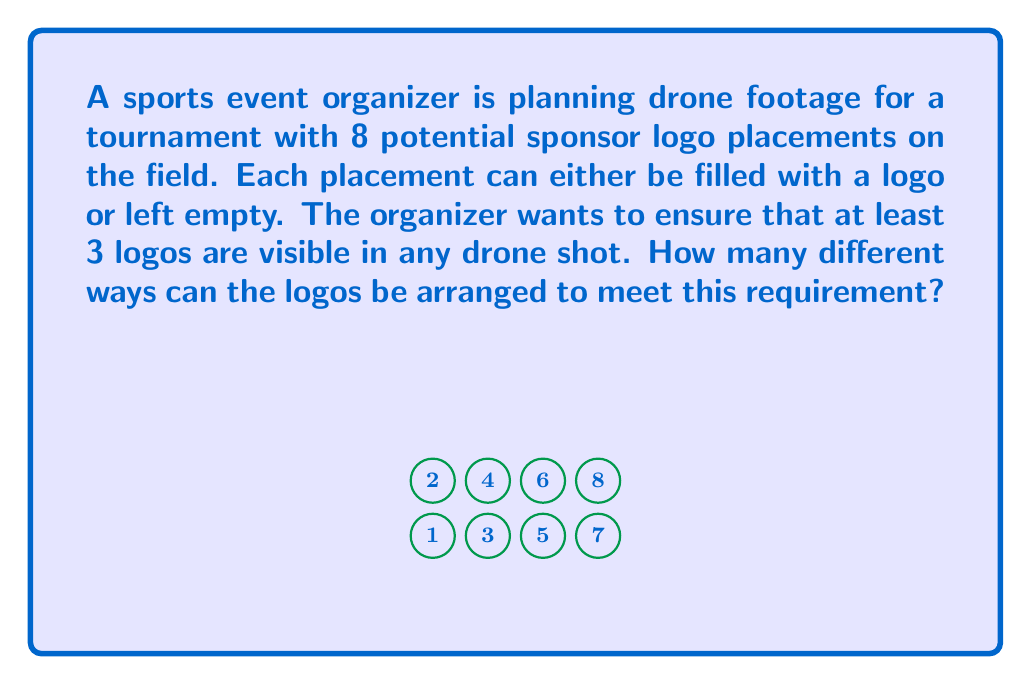Teach me how to tackle this problem. Let's approach this step-by-step:

1) First, we need to calculate the total number of ways to arrange logos in 8 spots. Each spot can be either filled or empty, so we have 2 choices for each spot. This gives us $2^8 = 256$ total arrangements.

2) However, we need to subtract the arrangements where fewer than 3 logos are used. Let's count these:
   - 0 logos: $\binom{8}{0} = 1$ way
   - 1 logo: $\binom{8}{1} = 8$ ways
   - 2 logos: $\binom{8}{2} = 28$ ways

3) The total number of arrangements with fewer than 3 logos is:
   $1 + 8 + 28 = 37$

4) Therefore, the number of valid arrangements is:
   $256 - 37 = 219$

This can also be expressed using the sum of combinations:

$$\sum_{k=3}^{8} \binom{8}{k} = \binom{8}{3} + \binom{8}{4} + \binom{8}{5} + \binom{8}{6} + \binom{8}{7} + \binom{8}{8}$$

Which equals 219 when calculated.
Answer: 219 